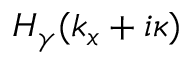Convert formula to latex. <formula><loc_0><loc_0><loc_500><loc_500>H _ { \gamma } ( k _ { x } + i \kappa )</formula> 